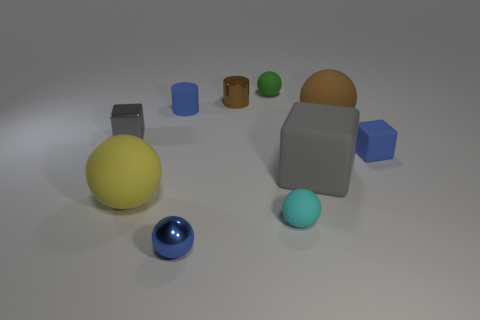There is a yellow rubber object; what shape is it?
Your answer should be compact. Sphere. What is the gray thing that is to the left of the metal cylinder made of?
Give a very brief answer. Metal. Are there any things that have the same color as the big rubber block?
Your answer should be very brief. Yes. The green matte object that is the same size as the blue matte cylinder is what shape?
Provide a succinct answer. Sphere. There is a large rubber object that is to the left of the tiny green rubber sphere; what color is it?
Make the answer very short. Yellow. There is a tiny metal thing that is in front of the large yellow ball; is there a blue block that is left of it?
Give a very brief answer. No. What number of things are large things that are left of the tiny green rubber ball or yellow cylinders?
Provide a succinct answer. 1. There is a gray object on the left side of the rubber ball in front of the large yellow rubber thing; what is it made of?
Offer a terse response. Metal. Is the number of tiny green matte objects to the left of the green sphere the same as the number of metal balls on the right side of the cyan thing?
Give a very brief answer. Yes. What number of things are either small blue rubber objects that are behind the large brown matte sphere or small things right of the green matte thing?
Give a very brief answer. 3. 